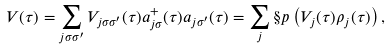<formula> <loc_0><loc_0><loc_500><loc_500>V ( \tau ) = \sum _ { j \sigma \sigma ^ { \prime } } V _ { j \sigma \sigma ^ { \prime } } ( \tau ) a ^ { + } _ { j \sigma } ( \tau ) a _ { j \sigma ^ { \prime } } ( \tau ) = \sum _ { j } \S p \left ( V _ { j } ( \tau ) \rho _ { j } ( \tau ) \right ) ,</formula> 